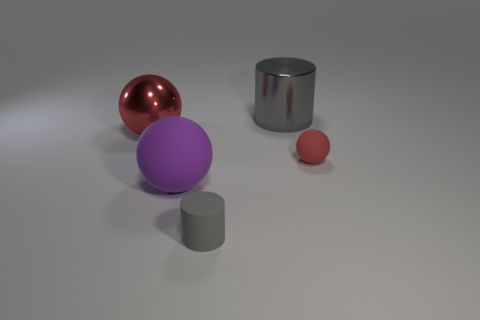What could be the possible use of these objects if they were real? If these objects were real, the spheres might be used as decorative ornaments due to their polished appearance or as models in a physics demonstration to showcase properties of light and reflection. The cylinders, with their neutral colors and simple shapes, could serve as pedestals for displaying items or as components in larger mechanical structures. 